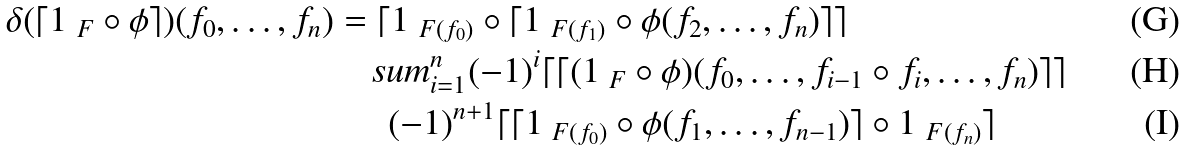<formula> <loc_0><loc_0><loc_500><loc_500>\delta ( \lceil 1 _ { \ F } \circ \phi \rceil ) ( f _ { 0 } , \dots , f _ { n } ) & = \lceil 1 _ { \ F ( f _ { 0 } ) } \circ \lceil 1 _ { \ F ( f _ { 1 } ) } \circ \phi ( f _ { 2 } , \dots , f _ { n } ) \rceil \rceil \\ & \quad s u m _ { i = 1 } ^ { n } ( - 1 ) ^ { i } \lceil \lceil ( 1 _ { \ F } \circ \phi ) ( f _ { 0 } , \dots , f _ { i - 1 } \circ f _ { i } , \dots , f _ { n } ) \rceil \rceil \\ & \quad \ \ ( - 1 ) ^ { n + 1 } \lceil \lceil 1 _ { \ F ( f _ { 0 } ) } \circ \phi ( f _ { 1 } , \dots , f _ { n - 1 } ) \rceil \circ 1 _ { \ F ( f _ { n } ) } \rceil</formula> 